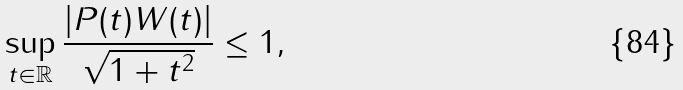Convert formula to latex. <formula><loc_0><loc_0><loc_500><loc_500>\sup _ { t \in \mathbb { R } } \frac { \left | P ( t ) W ( t ) \right | } { \sqrt { 1 + t ^ { 2 } } } \leq 1 ,</formula> 